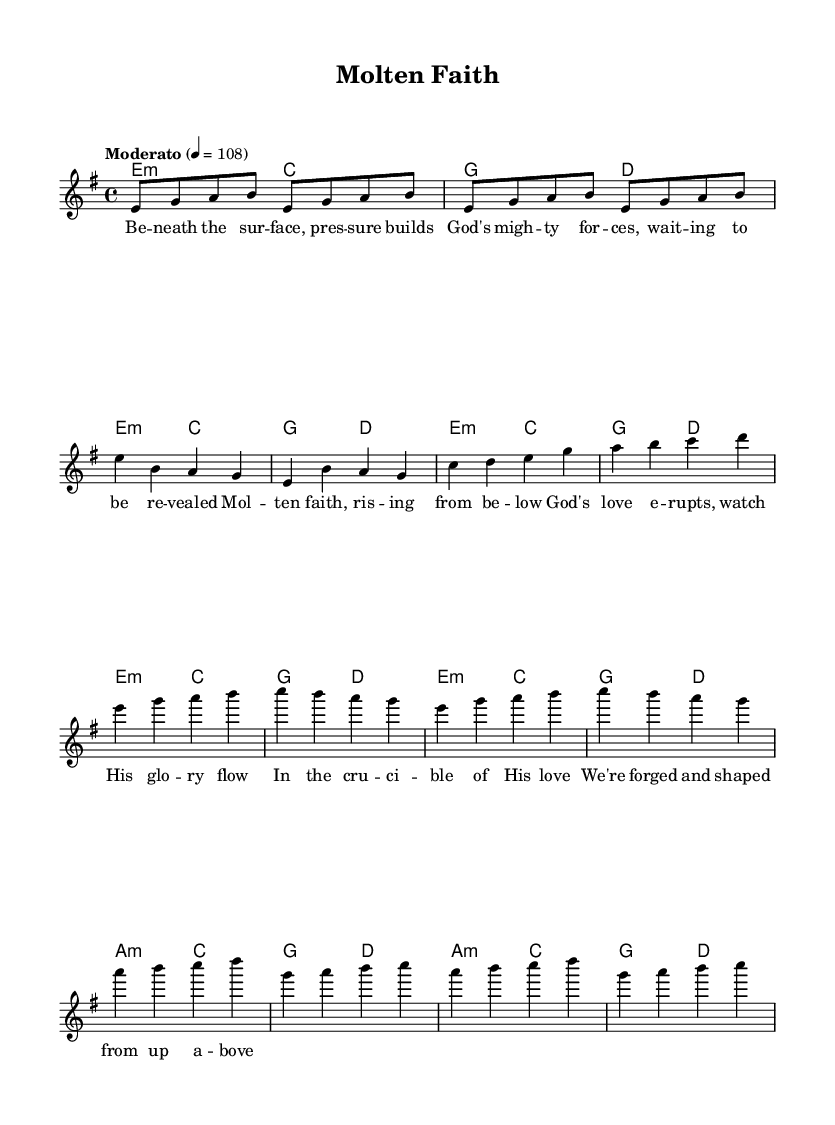What is the key signature of this music? The key signature is specified at the beginning of the score, indicating the presence of certain sharps or flats. In this case, it shows that the piece is in E minor, which has one sharp.
Answer: E minor What is the time signature of this music? The time signature is indicated next to the key signature. Here, the 4/4 indicates there are four beats in each measure, and a quarter note gets one beat.
Answer: 4/4 What is the tempo marking of this music? The tempo marking is found at the beginning of the score and provides the speed of the piece. In this instance, it states "Moderato" at a metronome marking of 108 beats per minute.
Answer: Moderato 108 How many sections are there in this piece? By examining the structure of the score, there are three distinct sections labeled as Verse, Chorus, and Bridge, which are typical in contemporary Christian music.
Answer: Three What is the primary theme of the lyrics in this piece? Analyzing the lyrics provided, they reflect themes of faith, God's power, and transformation, strongly related to volcanic forces and spiritual growth, as indicated by the imagery.
Answer: Faith and God's power What harmonic structure does the verse follow? Examining the harmonies provided, the verse consists of the chord progression E minor and C, followed by G and D, repeating this structure across its measures.
Answer: E minor, C, G, D In what context might this song be performed? Considering its themes, lyrical content, and musical style, this piece would fit well in a worship service or fellowship gatherings where contemporary Christian music is appreciated.
Answer: Worship service 